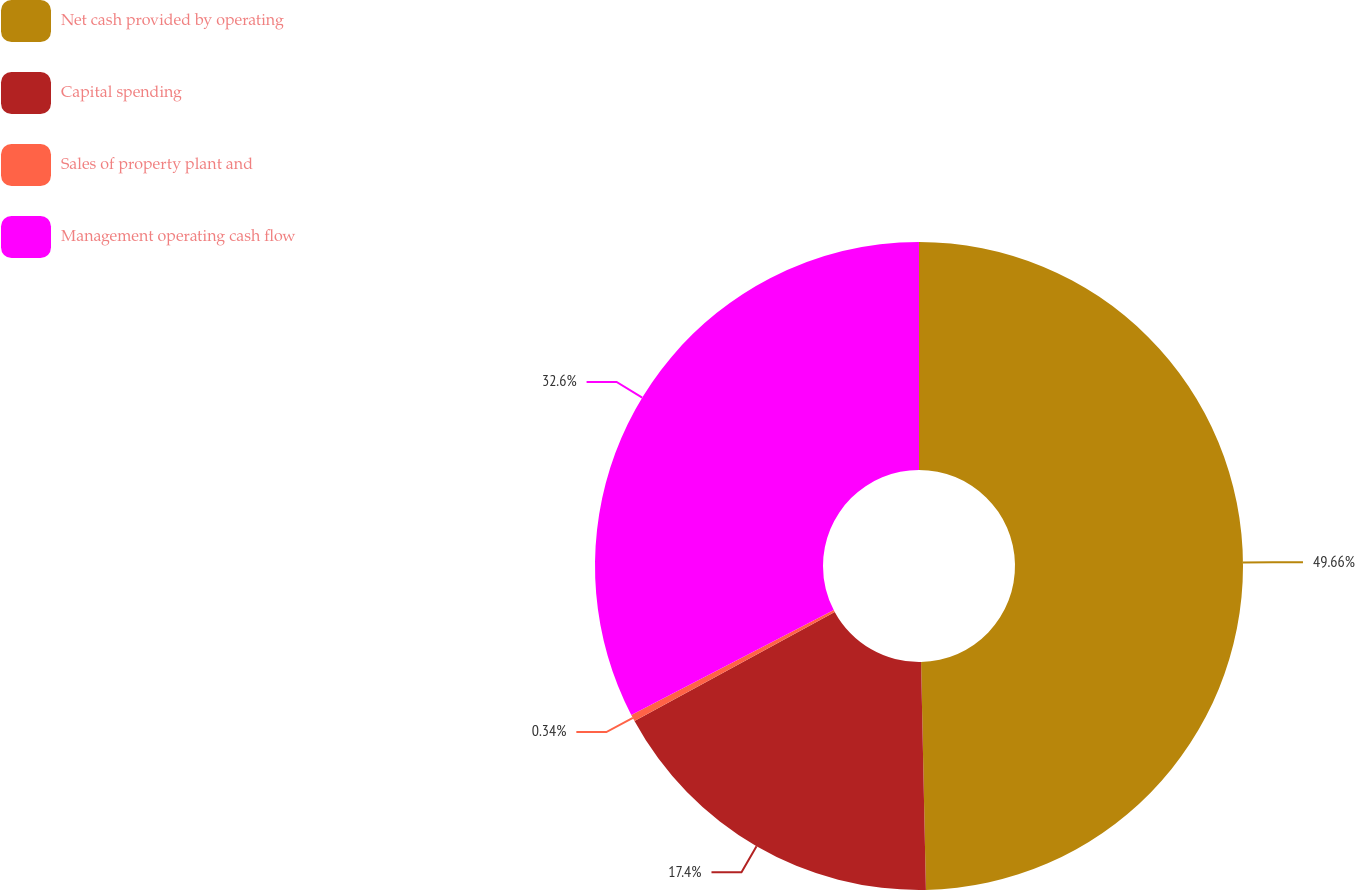Convert chart. <chart><loc_0><loc_0><loc_500><loc_500><pie_chart><fcel>Net cash provided by operating<fcel>Capital spending<fcel>Sales of property plant and<fcel>Management operating cash flow<nl><fcel>49.66%<fcel>17.4%<fcel>0.34%<fcel>32.6%<nl></chart> 